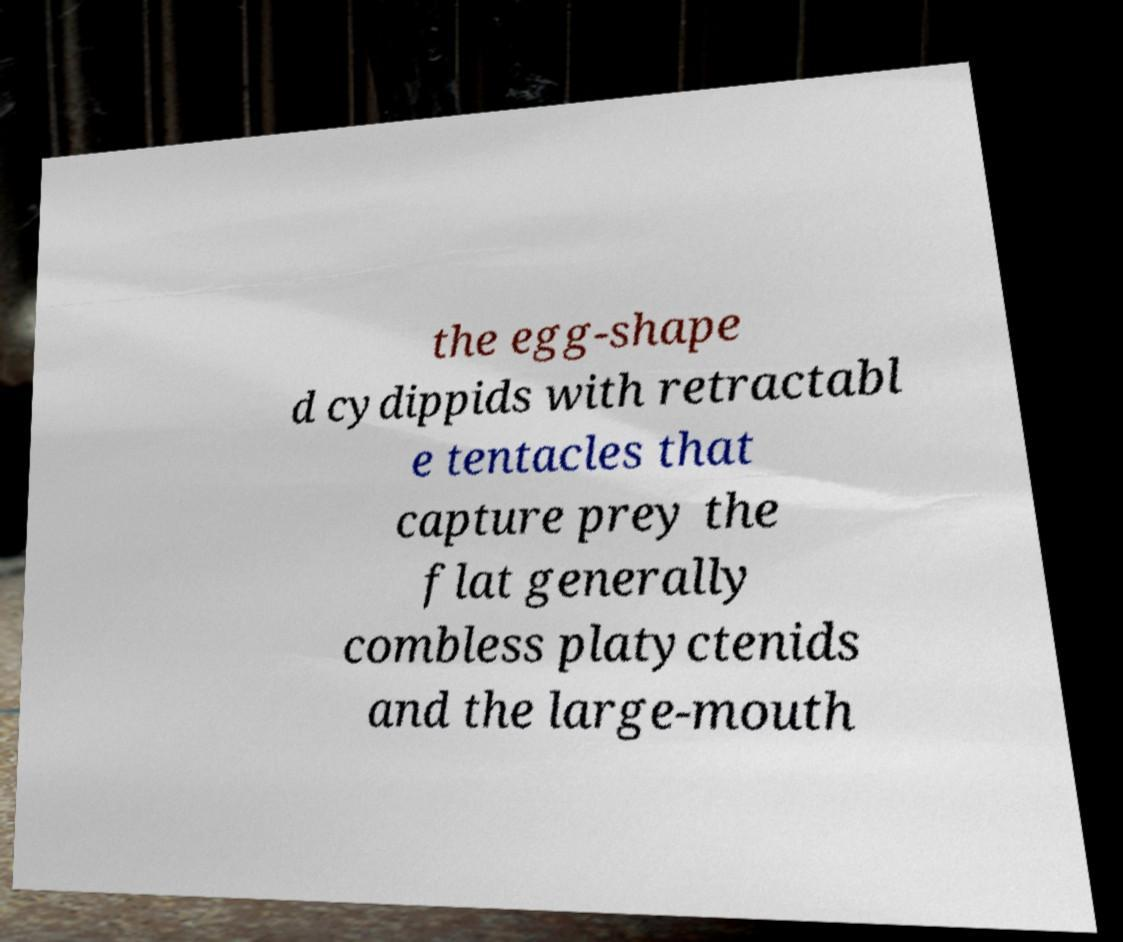Can you read and provide the text displayed in the image?This photo seems to have some interesting text. Can you extract and type it out for me? the egg-shape d cydippids with retractabl e tentacles that capture prey the flat generally combless platyctenids and the large-mouth 